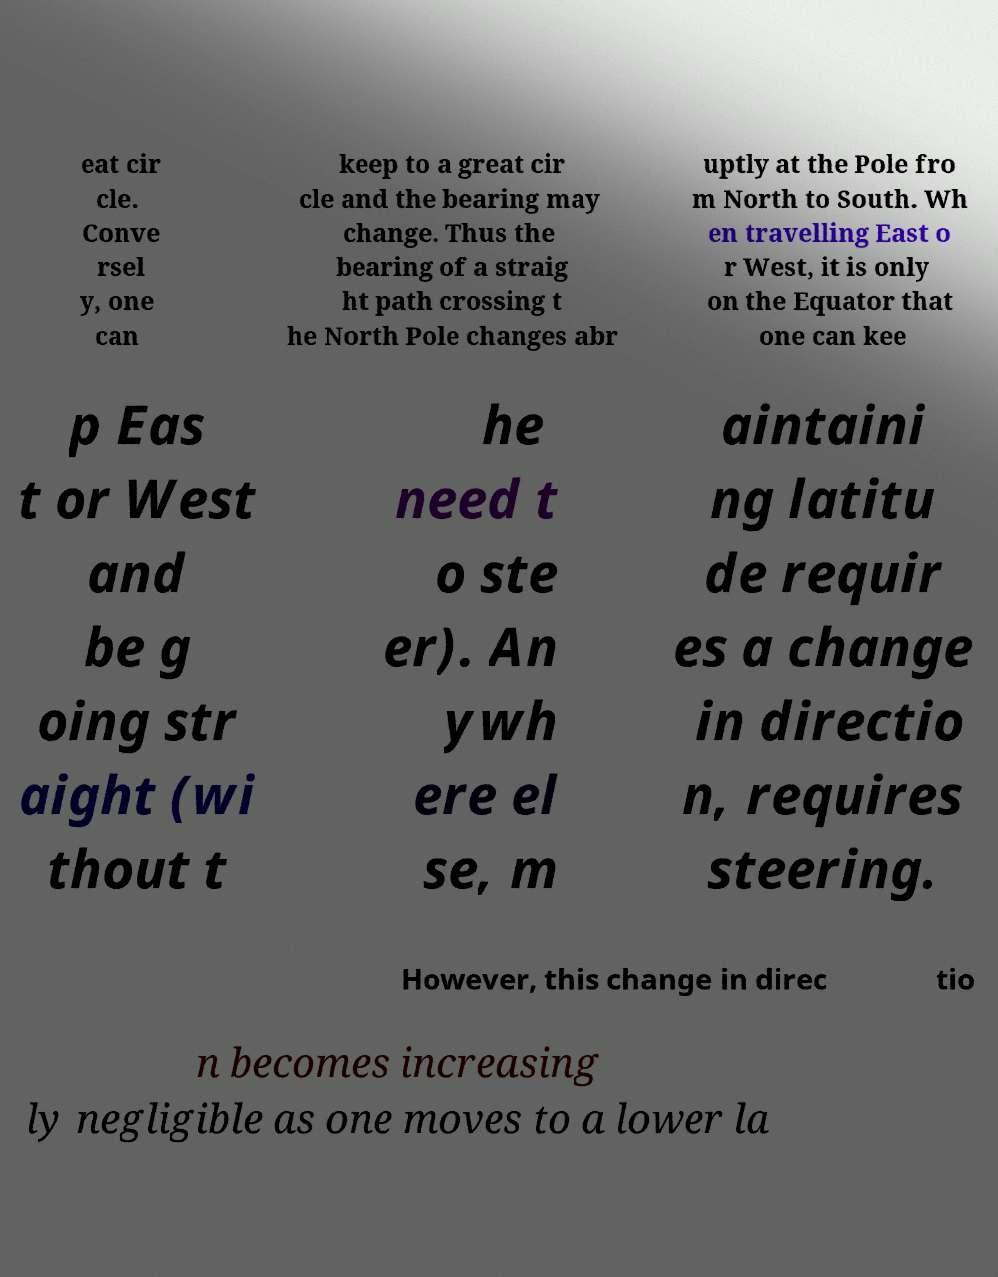For documentation purposes, I need the text within this image transcribed. Could you provide that? eat cir cle. Conve rsel y, one can keep to a great cir cle and the bearing may change. Thus the bearing of a straig ht path crossing t he North Pole changes abr uptly at the Pole fro m North to South. Wh en travelling East o r West, it is only on the Equator that one can kee p Eas t or West and be g oing str aight (wi thout t he need t o ste er). An ywh ere el se, m aintaini ng latitu de requir es a change in directio n, requires steering. However, this change in direc tio n becomes increasing ly negligible as one moves to a lower la 